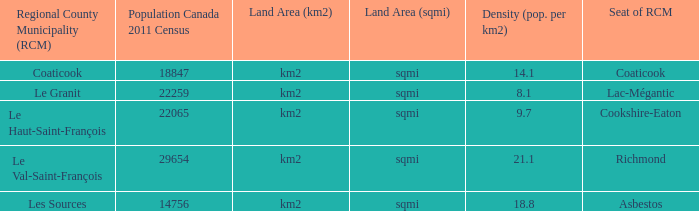What is the land area of the RCM having a density of 21.1? Km2 (sqmi). 